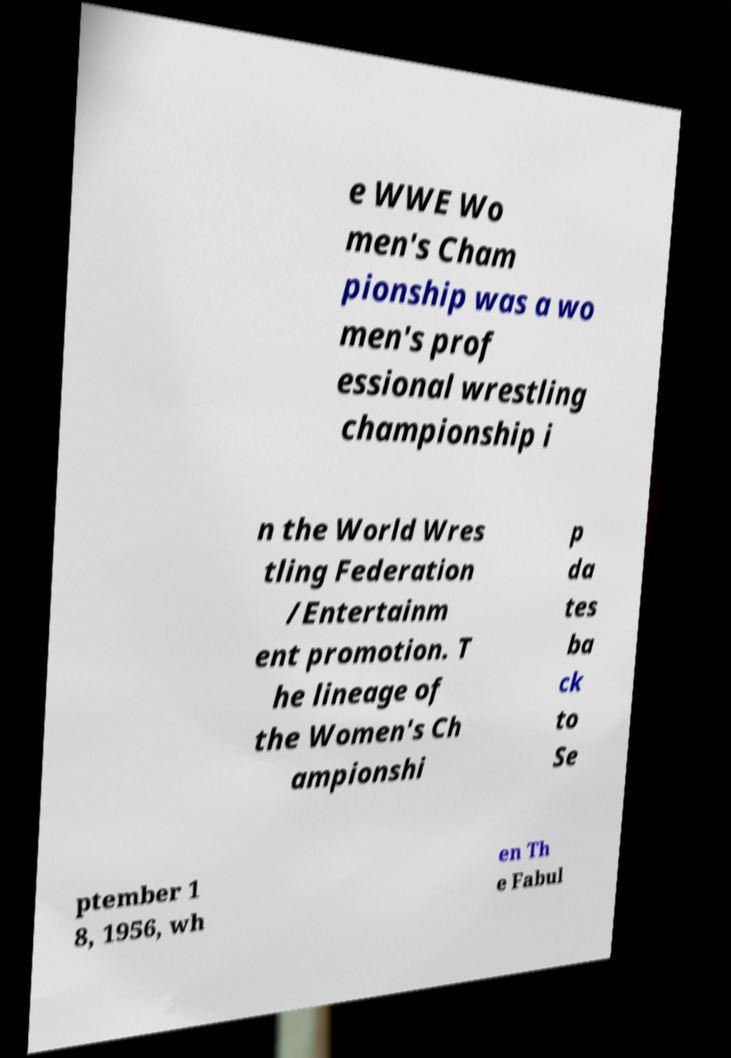Please read and relay the text visible in this image. What does it say? e WWE Wo men's Cham pionship was a wo men's prof essional wrestling championship i n the World Wres tling Federation /Entertainm ent promotion. T he lineage of the Women's Ch ampionshi p da tes ba ck to Se ptember 1 8, 1956, wh en Th e Fabul 